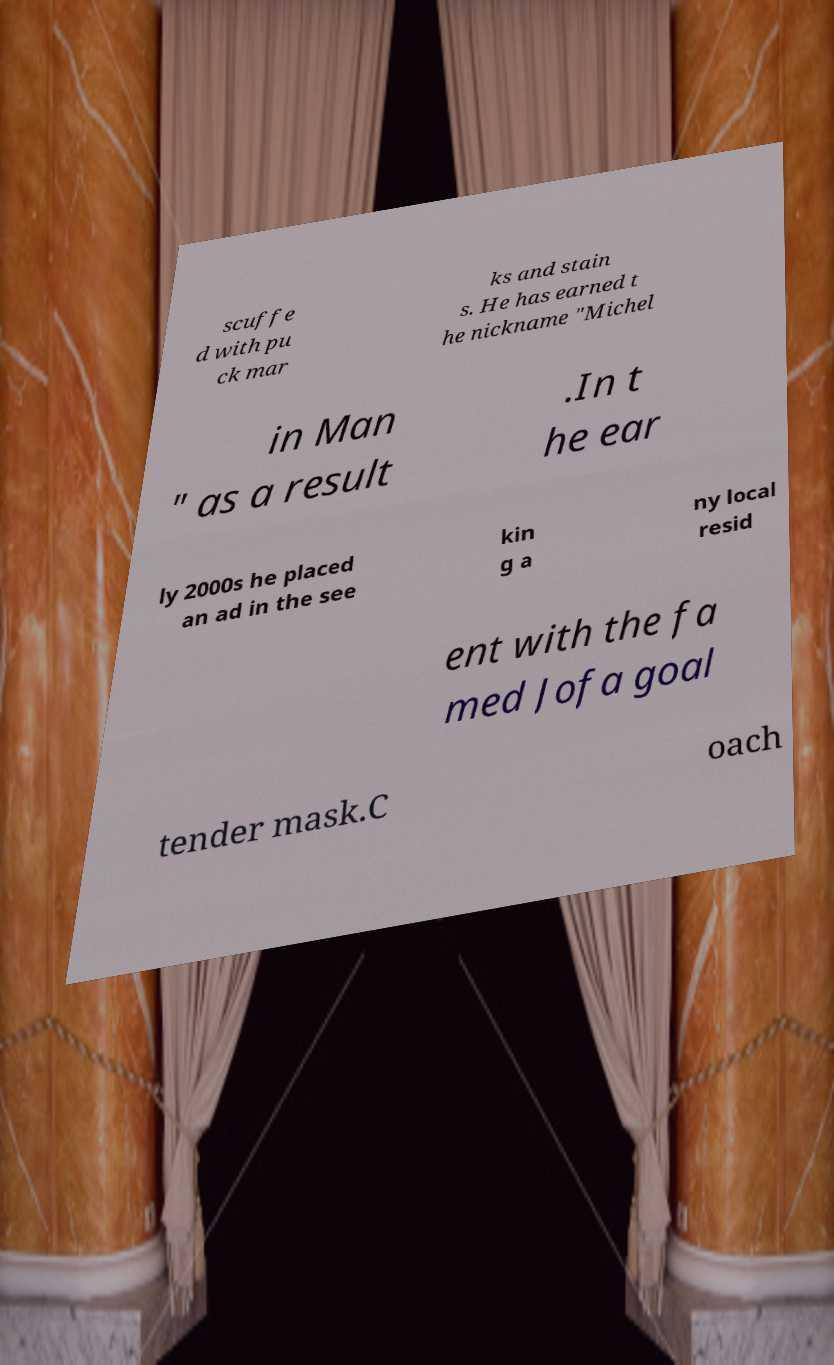For documentation purposes, I need the text within this image transcribed. Could you provide that? scuffe d with pu ck mar ks and stain s. He has earned t he nickname "Michel in Man " as a result .In t he ear ly 2000s he placed an ad in the see kin g a ny local resid ent with the fa med Jofa goal tender mask.C oach 